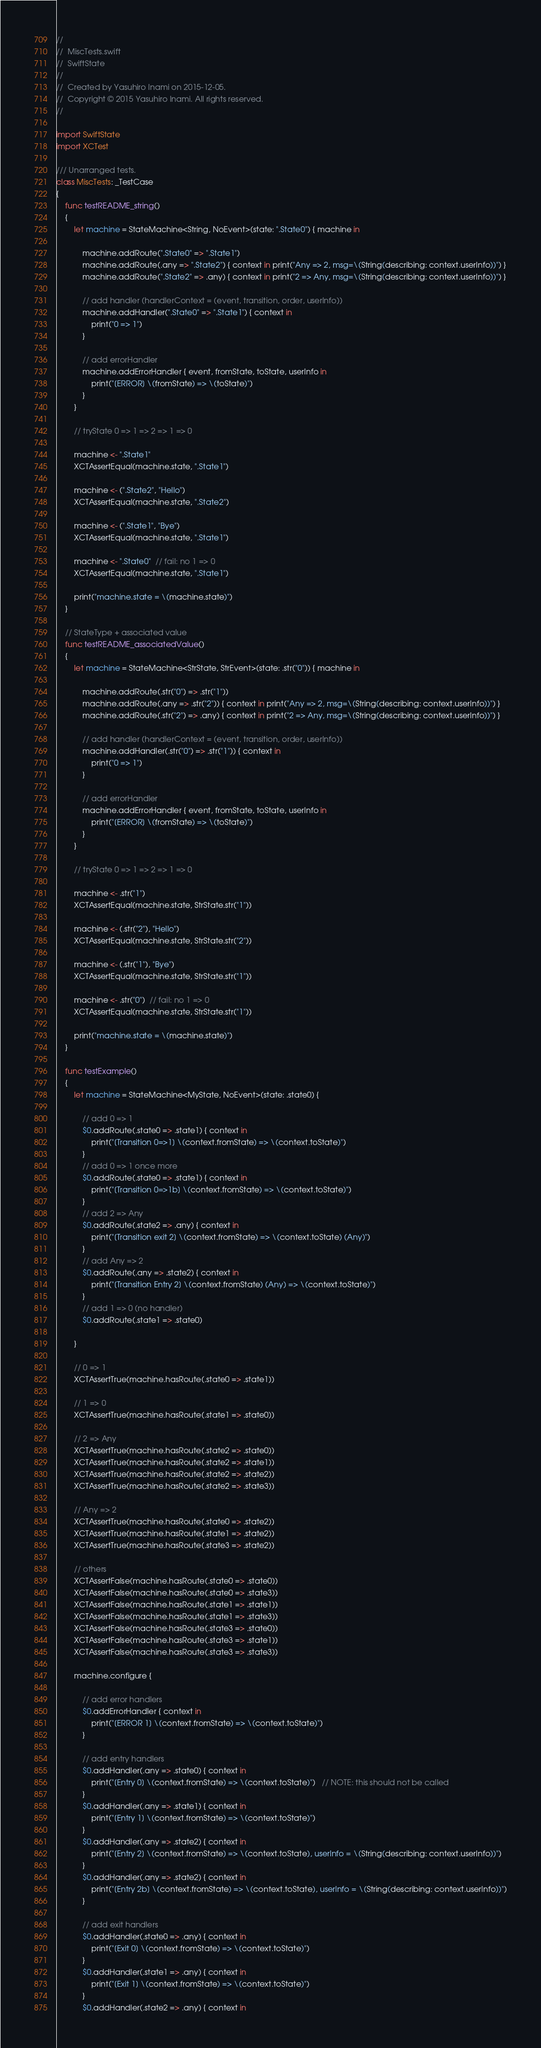<code> <loc_0><loc_0><loc_500><loc_500><_Swift_>//
//  MiscTests.swift
//  SwiftState
//
//  Created by Yasuhiro Inami on 2015-12-05.
//  Copyright © 2015 Yasuhiro Inami. All rights reserved.
//

import SwiftState
import XCTest

/// Unarranged tests.
class MiscTests: _TestCase
{
    func testREADME_string()
    {
        let machine = StateMachine<String, NoEvent>(state: ".State0") { machine in

            machine.addRoute(".State0" => ".State1")
            machine.addRoute(.any => ".State2") { context in print("Any => 2, msg=\(String(describing: context.userInfo))") }
            machine.addRoute(".State2" => .any) { context in print("2 => Any, msg=\(String(describing: context.userInfo))") }

            // add handler (handlerContext = (event, transition, order, userInfo))
            machine.addHandler(".State0" => ".State1") { context in
                print("0 => 1")
            }

            // add errorHandler
            machine.addErrorHandler { event, fromState, toState, userInfo in
                print("[ERROR] \(fromState) => \(toState)")
            }
        }

        // tryState 0 => 1 => 2 => 1 => 0

        machine <- ".State1"
        XCTAssertEqual(machine.state, ".State1")

        machine <- (".State2", "Hello")
        XCTAssertEqual(machine.state, ".State2")

        machine <- (".State1", "Bye")
        XCTAssertEqual(machine.state, ".State1")

        machine <- ".State0"  // fail: no 1 => 0
        XCTAssertEqual(machine.state, ".State1")

        print("machine.state = \(machine.state)")
    }

    // StateType + associated value
    func testREADME_associatedValue()
    {
        let machine = StateMachine<StrState, StrEvent>(state: .str("0")) { machine in

            machine.addRoute(.str("0") => .str("1"))
            machine.addRoute(.any => .str("2")) { context in print("Any => 2, msg=\(String(describing: context.userInfo))") }
            machine.addRoute(.str("2") => .any) { context in print("2 => Any, msg=\(String(describing: context.userInfo))") }

            // add handler (handlerContext = (event, transition, order, userInfo))
            machine.addHandler(.str("0") => .str("1")) { context in
                print("0 => 1")
            }

            // add errorHandler
            machine.addErrorHandler { event, fromState, toState, userInfo in
                print("[ERROR] \(fromState) => \(toState)")
            }
        }

        // tryState 0 => 1 => 2 => 1 => 0

        machine <- .str("1")
        XCTAssertEqual(machine.state, StrState.str("1"))

        machine <- (.str("2"), "Hello")
        XCTAssertEqual(machine.state, StrState.str("2"))

        machine <- (.str("1"), "Bye")
        XCTAssertEqual(machine.state, StrState.str("1"))

        machine <- .str("0")  // fail: no 1 => 0
        XCTAssertEqual(machine.state, StrState.str("1"))

        print("machine.state = \(machine.state)")
    }

    func testExample()
    {
        let machine = StateMachine<MyState, NoEvent>(state: .state0) {

            // add 0 => 1
            $0.addRoute(.state0 => .state1) { context in
                print("[Transition 0=>1] \(context.fromState) => \(context.toState)")
            }
            // add 0 => 1 once more
            $0.addRoute(.state0 => .state1) { context in
                print("[Transition 0=>1b] \(context.fromState) => \(context.toState)")
            }
            // add 2 => Any
            $0.addRoute(.state2 => .any) { context in
                print("[Transition exit 2] \(context.fromState) => \(context.toState) (Any)")
            }
            // add Any => 2
            $0.addRoute(.any => .state2) { context in
                print("[Transition Entry 2] \(context.fromState) (Any) => \(context.toState)")
            }
            // add 1 => 0 (no handler)
            $0.addRoute(.state1 => .state0)

        }

        // 0 => 1
        XCTAssertTrue(machine.hasRoute(.state0 => .state1))

        // 1 => 0
        XCTAssertTrue(machine.hasRoute(.state1 => .state0))

        // 2 => Any
        XCTAssertTrue(machine.hasRoute(.state2 => .state0))
        XCTAssertTrue(machine.hasRoute(.state2 => .state1))
        XCTAssertTrue(machine.hasRoute(.state2 => .state2))
        XCTAssertTrue(machine.hasRoute(.state2 => .state3))

        // Any => 2
        XCTAssertTrue(machine.hasRoute(.state0 => .state2))
        XCTAssertTrue(machine.hasRoute(.state1 => .state2))
        XCTAssertTrue(machine.hasRoute(.state3 => .state2))

        // others
        XCTAssertFalse(machine.hasRoute(.state0 => .state0))
        XCTAssertFalse(machine.hasRoute(.state0 => .state3))
        XCTAssertFalse(machine.hasRoute(.state1 => .state1))
        XCTAssertFalse(machine.hasRoute(.state1 => .state3))
        XCTAssertFalse(machine.hasRoute(.state3 => .state0))
        XCTAssertFalse(machine.hasRoute(.state3 => .state1))
        XCTAssertFalse(machine.hasRoute(.state3 => .state3))

        machine.configure {

            // add error handlers
            $0.addErrorHandler { context in
                print("[ERROR 1] \(context.fromState) => \(context.toState)")
            }

            // add entry handlers
            $0.addHandler(.any => .state0) { context in
                print("[Entry 0] \(context.fromState) => \(context.toState)")   // NOTE: this should not be called
            }
            $0.addHandler(.any => .state1) { context in
                print("[Entry 1] \(context.fromState) => \(context.toState)")
            }
            $0.addHandler(.any => .state2) { context in
                print("[Entry 2] \(context.fromState) => \(context.toState), userInfo = \(String(describing: context.userInfo))")
            }
            $0.addHandler(.any => .state2) { context in
                print("[Entry 2b] \(context.fromState) => \(context.toState), userInfo = \(String(describing: context.userInfo))")
            }

            // add exit handlers
            $0.addHandler(.state0 => .any) { context in
                print("[Exit 0] \(context.fromState) => \(context.toState)")
            }
            $0.addHandler(.state1 => .any) { context in
                print("[Exit 1] \(context.fromState) => \(context.toState)")
            }
            $0.addHandler(.state2 => .any) { context in</code> 